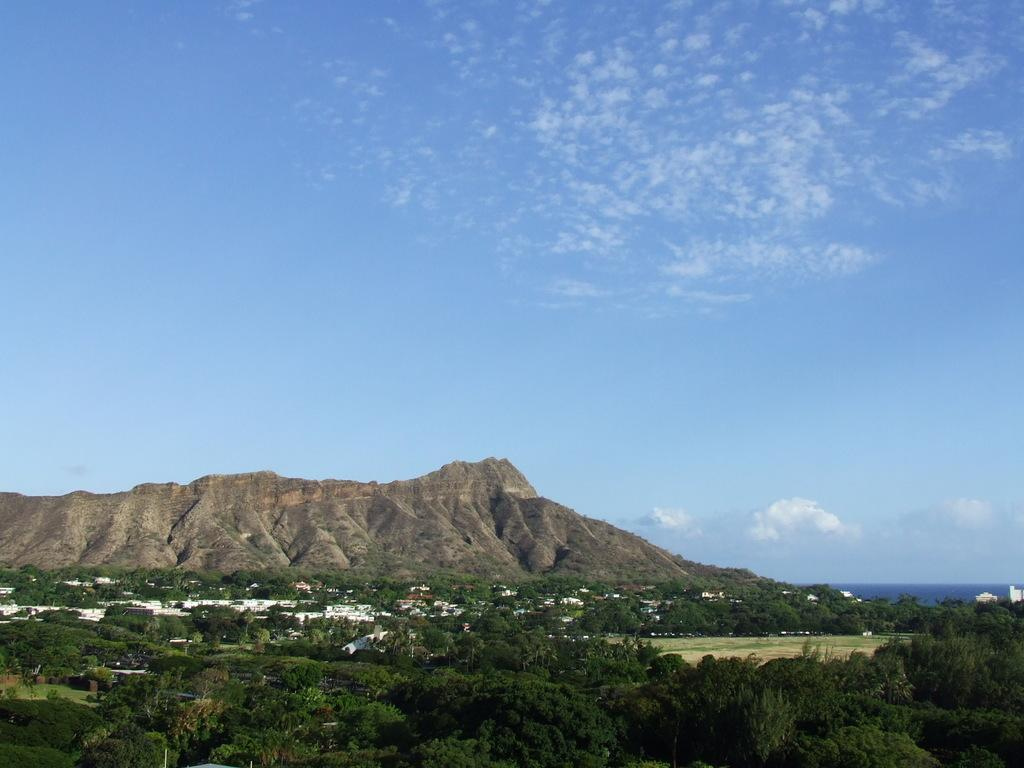What geographical feature is located in the center of the image? There are hills in the center of the image. What can be found at the bottom of the image? There are trees and buildings at the bottom of the image. What is visible in the background of the image? The sky is visible in the background of the image. Can you see any playground equipment in the image? There is no playground equipment present in the image. What is the aftermath of the storm in the image? There is no mention of a storm or any aftermath in the image. 